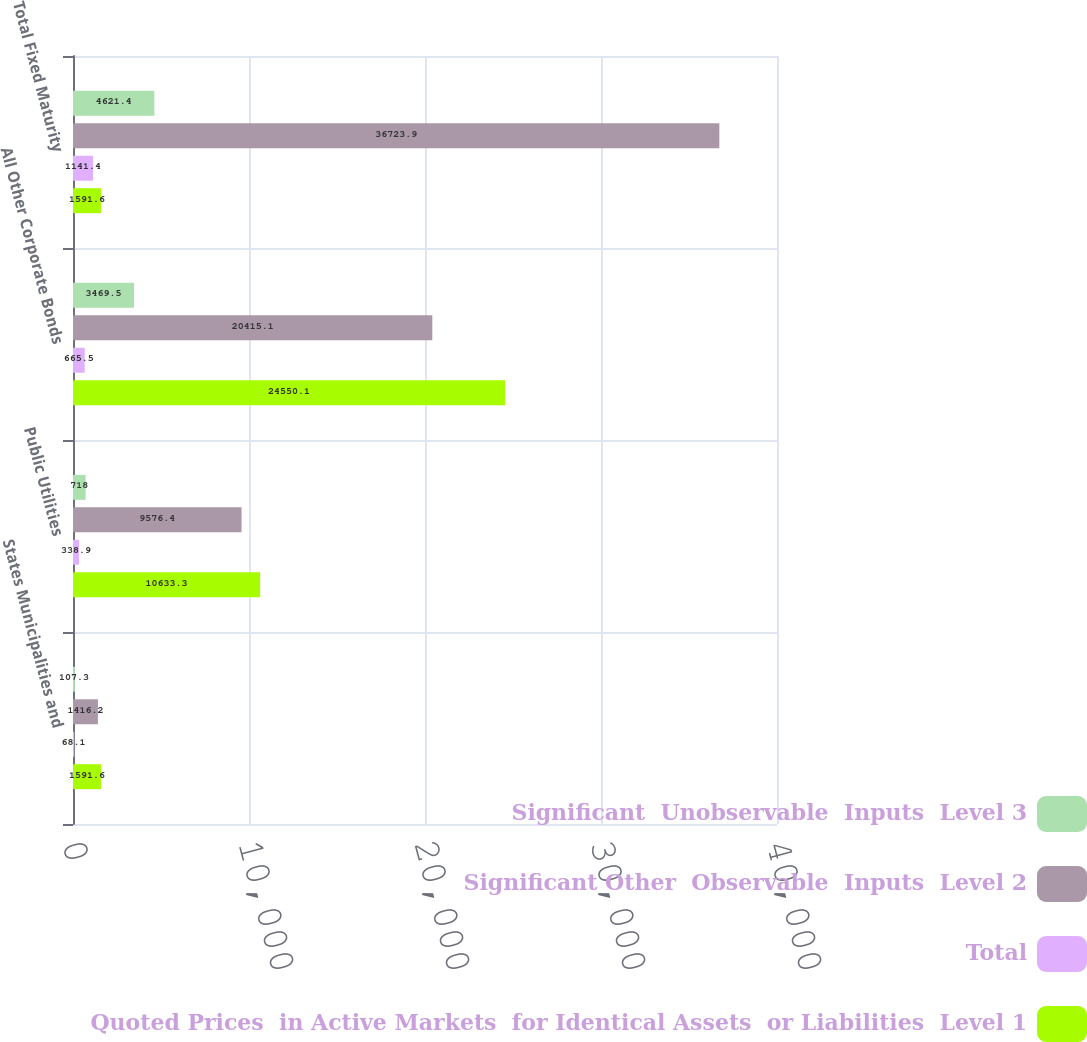Convert chart to OTSL. <chart><loc_0><loc_0><loc_500><loc_500><stacked_bar_chart><ecel><fcel>States Municipalities and<fcel>Public Utilities<fcel>All Other Corporate Bonds<fcel>Total Fixed Maturity<nl><fcel>Significant  Unobservable  Inputs  Level 3<fcel>107.3<fcel>718<fcel>3469.5<fcel>4621.4<nl><fcel>Significant Other  Observable  Inputs  Level 2<fcel>1416.2<fcel>9576.4<fcel>20415.1<fcel>36723.9<nl><fcel>Total<fcel>68.1<fcel>338.9<fcel>665.5<fcel>1141.4<nl><fcel>Quoted Prices  in Active Markets  for Identical Assets  or Liabilities  Level 1<fcel>1591.6<fcel>10633.3<fcel>24550.1<fcel>1591.6<nl></chart> 